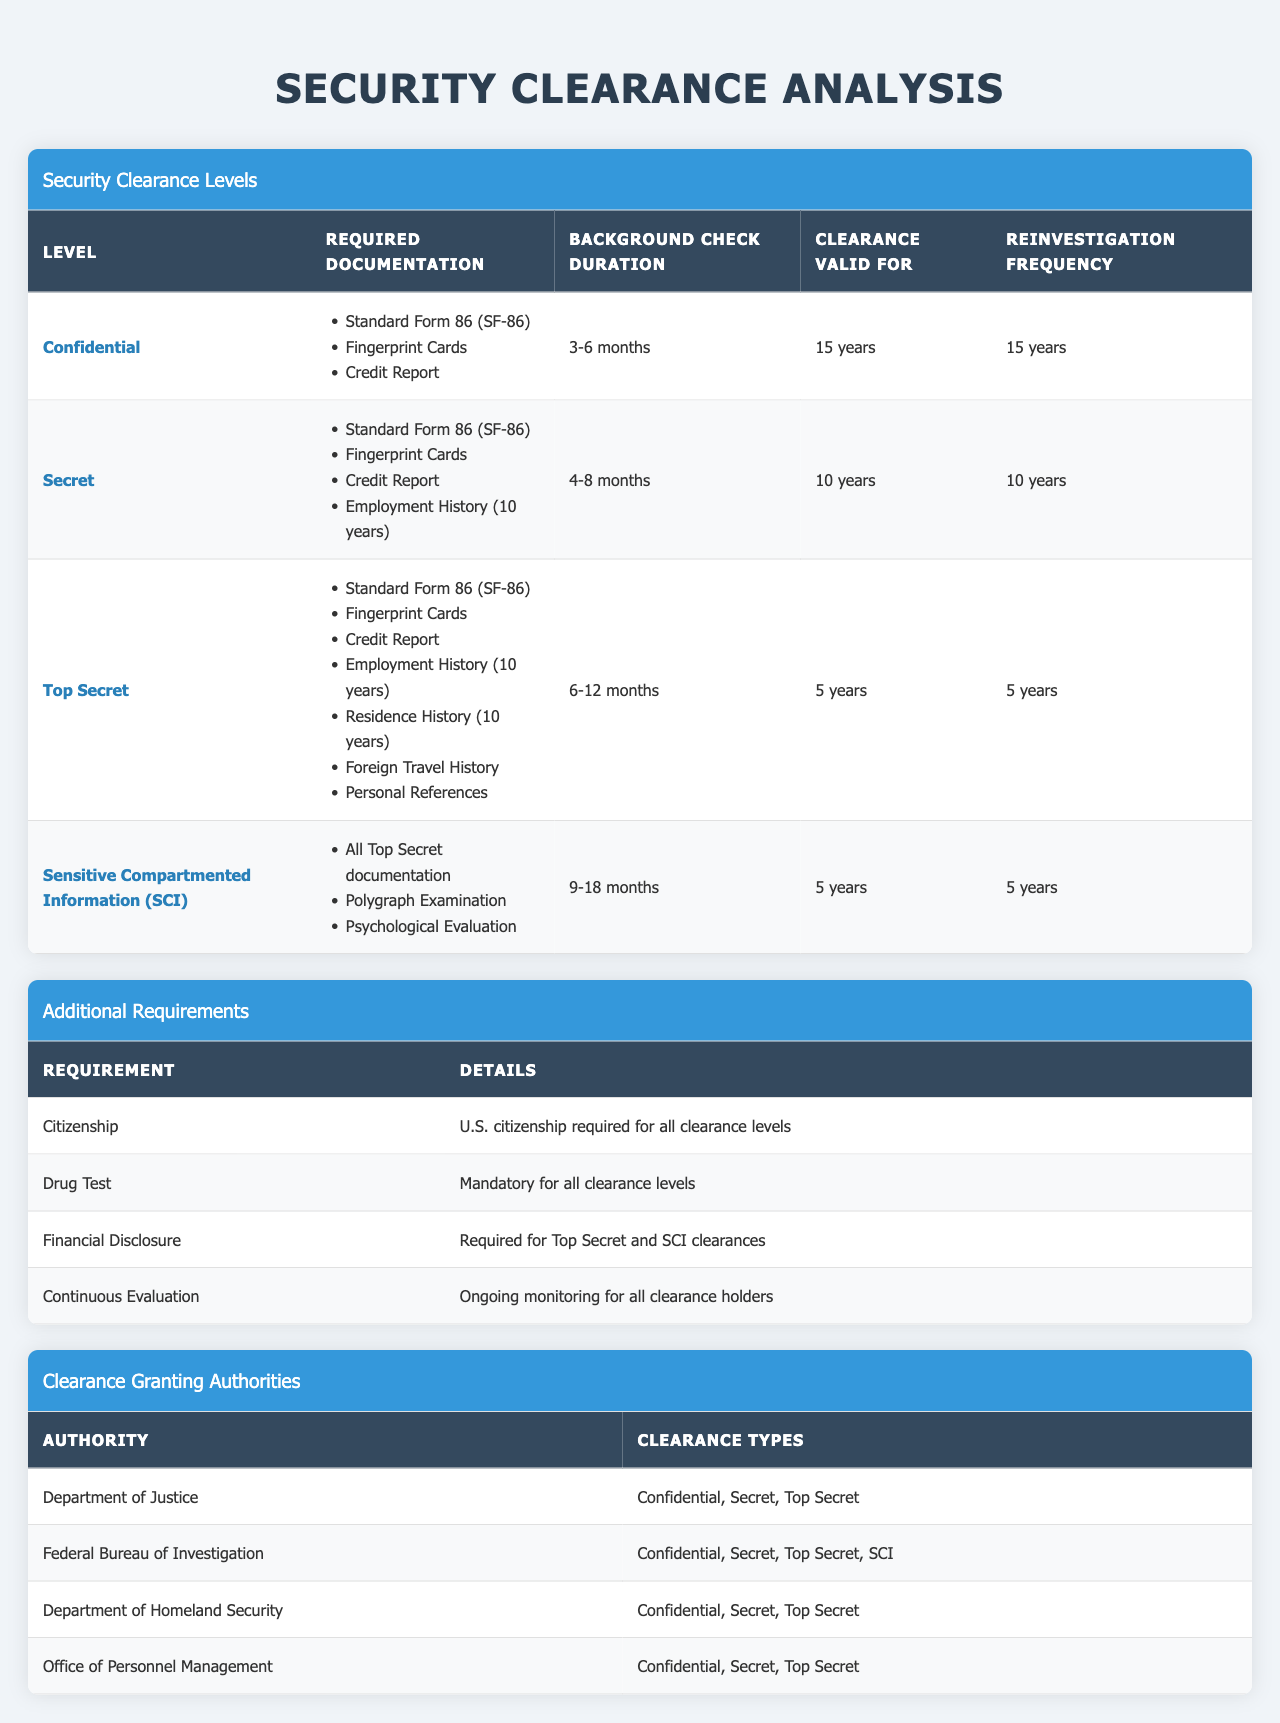What is the required documentation for a Top Secret clearance? According to the table, the required documentation for a Top Secret clearance includes: Standard Form 86 (SF-86), Fingerprint Cards, Credit Report, Employment History (10 years), Residence History (10 years), Foreign Travel History, and Personal References.
Answer: Standard Form 86 (SF-86), Fingerprint Cards, Credit Report, Employment History (10 years), Residence History (10 years), Foreign Travel History, and Personal References How long is the background check duration for a Sensitive Compartmented Information (SCI) clearance? The table indicates that the background check duration for a Sensitive Compartmented Information (SCI) clearance is between 9 to 18 months.
Answer: 9 to 18 months True or False: A Drug Test is mandatory for all security clearance levels. The table explicitly states that a Drug Test is mandatory for all clearance levels, confirming that the statement is true.
Answer: True What is the difference in clearance validity between Secret and Top Secret? The clearance validity for Secret is 10 years, while for Top Secret it is 5 years. The difference is 10 years - 5 years = 5 years.
Answer: 5 years Which authority grants the Sensitive Compartmented Information (SCI) clearance? The table shows that the Federal Bureau of Investigation is the only authority that grants the Sensitive Compartmented Information (SCI) clearance, among other types.
Answer: Federal Bureau of Investigation What is the required documentation for Secret clearance? The required documentation for Secret clearance includes: Standard Form 86 (SF-86), Fingerprint Cards, Credit Report, and Employment History (10 years).
Answer: Standard Form 86 (SF-86), Fingerprint Cards, Credit Report, and Employment History (10 years) Which clearance level requires a Polygraph Examination? The Polygraph Examination is required for the Sensitive Compartmented Information (SCI) clearance as per the table.
Answer: Sensitive Compartmented Information (SCI) How often must a Confidential clearance be reinvestigated? According to the table, a Confidential clearance must be reinvestigated every 15 years.
Answer: Every 15 years For which clearance levels is Financial Disclosure required? The table states that Financial Disclosure is required for Top Secret and Sensitive Compartmented Information (SCI) clearances.
Answer: Top Secret and Sensitive Compartmented Information (SCI) What is the average duration of background checks across all clearance levels? The background check durations are: Confidential (3-6 months), Secret (4-8 months), Top Secret (6-12 months), and SCI (9-18 months). To find the average duration (in months), we take the midpoints: 4.5, 6, 9, and 13. The sum is 32.5, and there are 4 clearances, so 32.5/4 = 8.125 months.
Answer: 8.125 months 